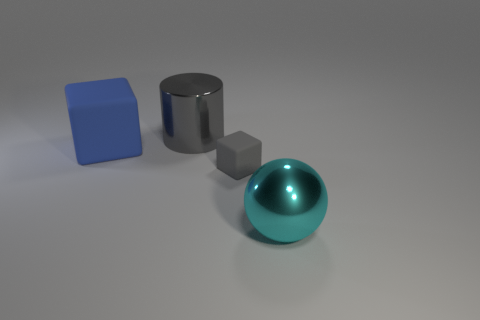How many other objects are the same size as the gray matte cube?
Your answer should be very brief. 0. Do the object that is in front of the small gray rubber object and the gray rubber object that is right of the big gray shiny cylinder have the same shape?
Keep it short and to the point. No. Are there any big cyan things to the right of the large ball?
Make the answer very short. No. What color is the tiny object that is the same shape as the big matte thing?
Offer a terse response. Gray. Are there any other things that are the same shape as the large blue matte object?
Keep it short and to the point. Yes. There is a big object behind the blue cube; what is it made of?
Give a very brief answer. Metal. What size is the other object that is the same shape as the blue object?
Provide a succinct answer. Small. How many large purple cubes have the same material as the big cylinder?
Your answer should be very brief. 0. How many small things are the same color as the shiny cylinder?
Keep it short and to the point. 1. What number of things are either rubber blocks that are to the left of the gray rubber object or things that are on the left side of the large cyan metallic thing?
Your answer should be compact. 3. 